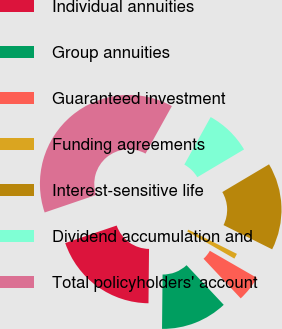Convert chart to OTSL. <chart><loc_0><loc_0><loc_500><loc_500><pie_chart><fcel>Individual annuities<fcel>Group annuities<fcel>Guaranteed investment<fcel>Funding agreements<fcel>Interest-sensitive life<fcel>Dividend accumulation and<fcel>Total policyholders' account<nl><fcel>19.61%<fcel>12.15%<fcel>4.69%<fcel>0.96%<fcel>15.88%<fcel>8.42%<fcel>38.27%<nl></chart> 